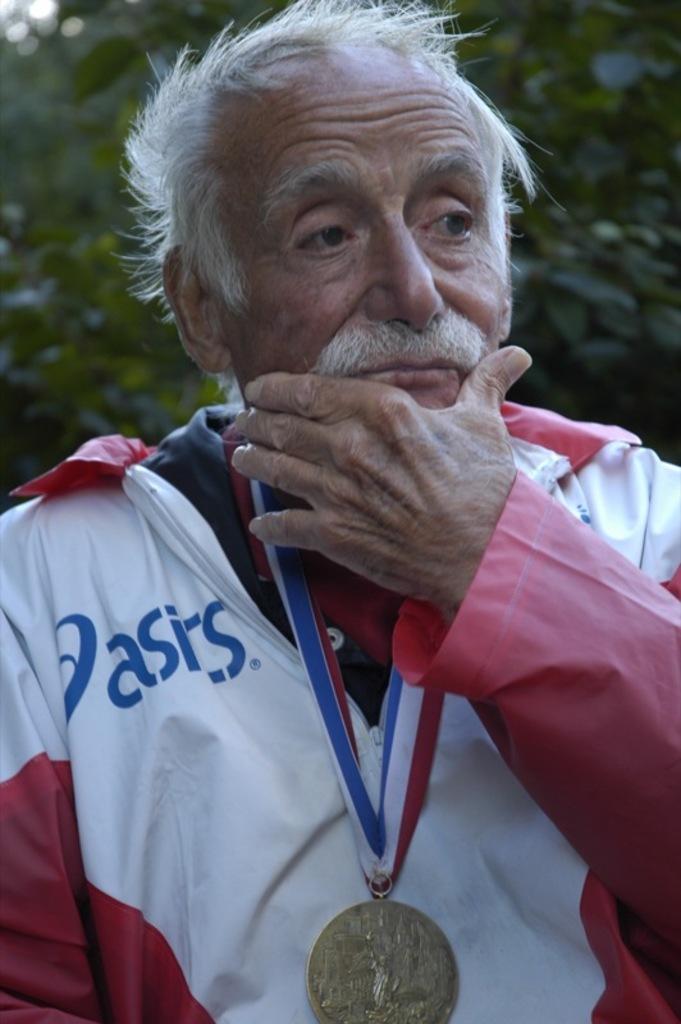What brand is the white and red coat?
Provide a succinct answer. Asics. 